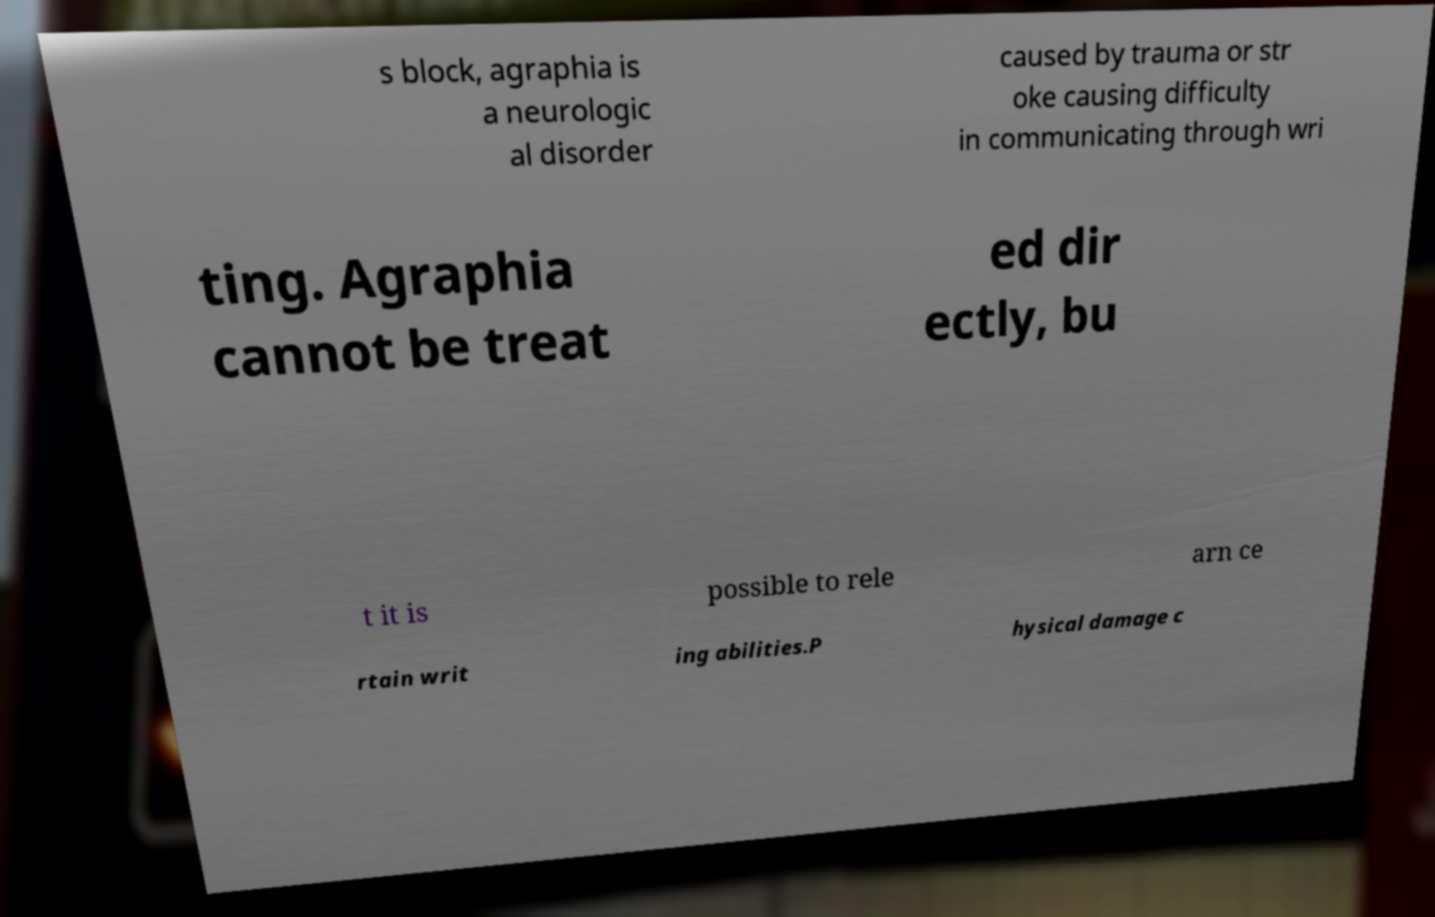What messages or text are displayed in this image? I need them in a readable, typed format. s block, agraphia is a neurologic al disorder caused by trauma or str oke causing difficulty in communicating through wri ting. Agraphia cannot be treat ed dir ectly, bu t it is possible to rele arn ce rtain writ ing abilities.P hysical damage c 